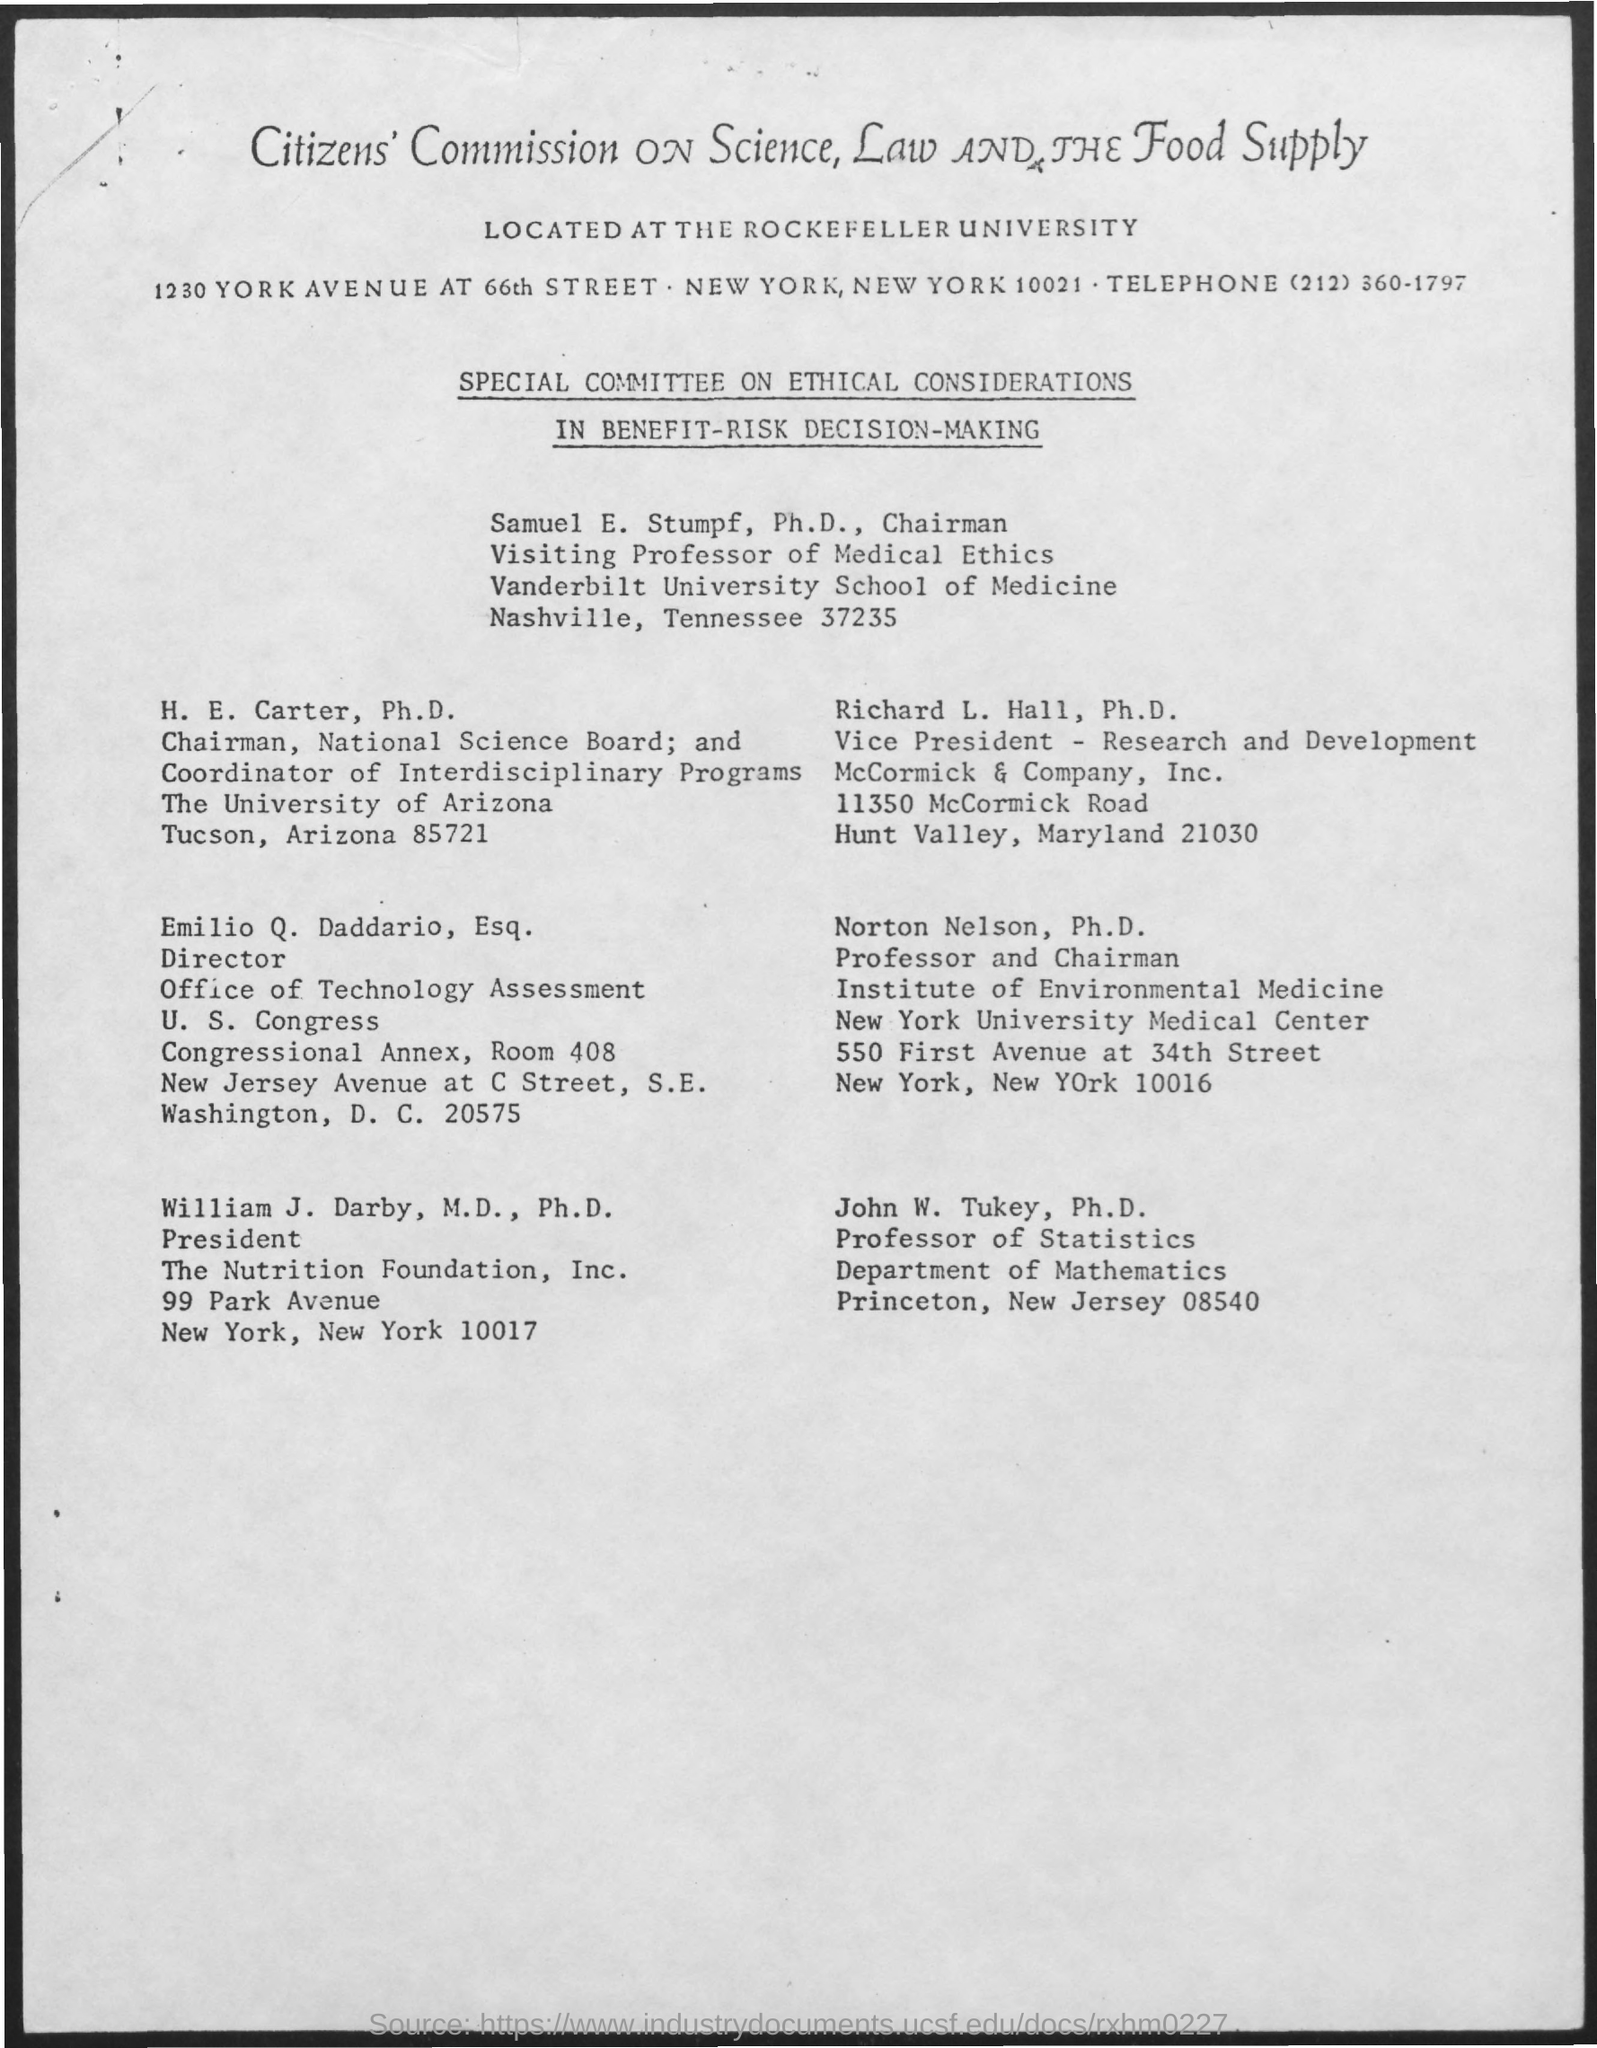what is the designation of john W. Turkey ? John W. Tukey holds the position of Professor of Statistics at Princeton University, specifically within their Department of Mathematics. His expertise and contributions have marked significant advancements in the field of statistics. 